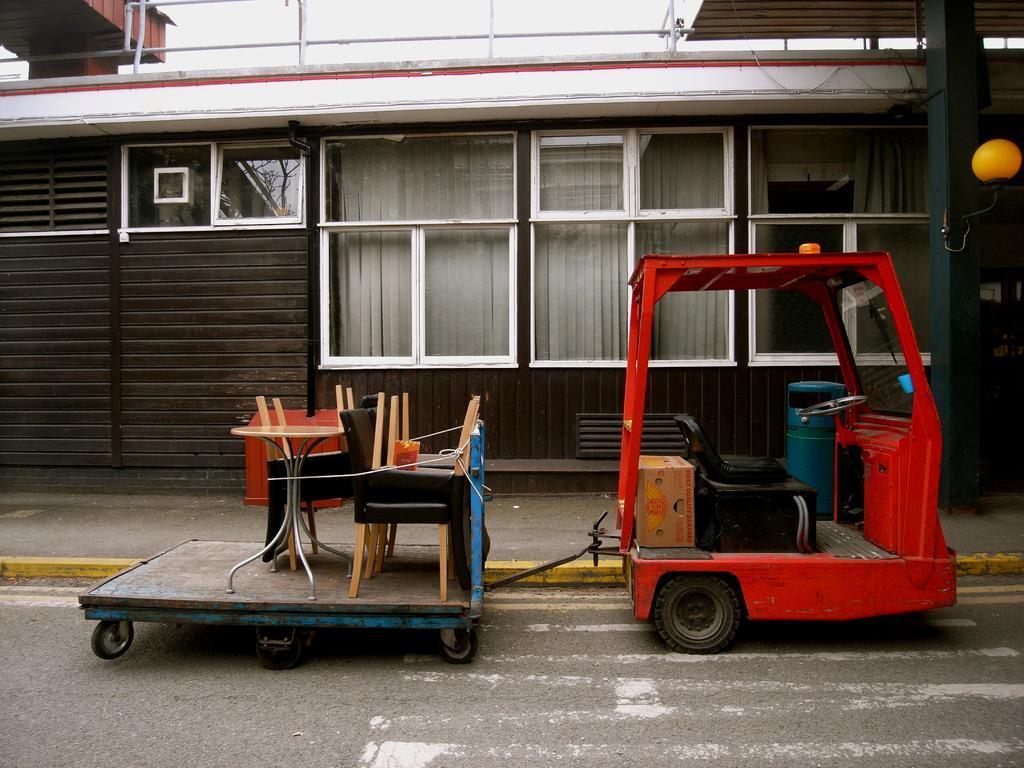In one or two sentences, can you explain what this image depicts? In this image there is a vehicle connected to a trolley, on which there are a few objects. In the background there is a building. 